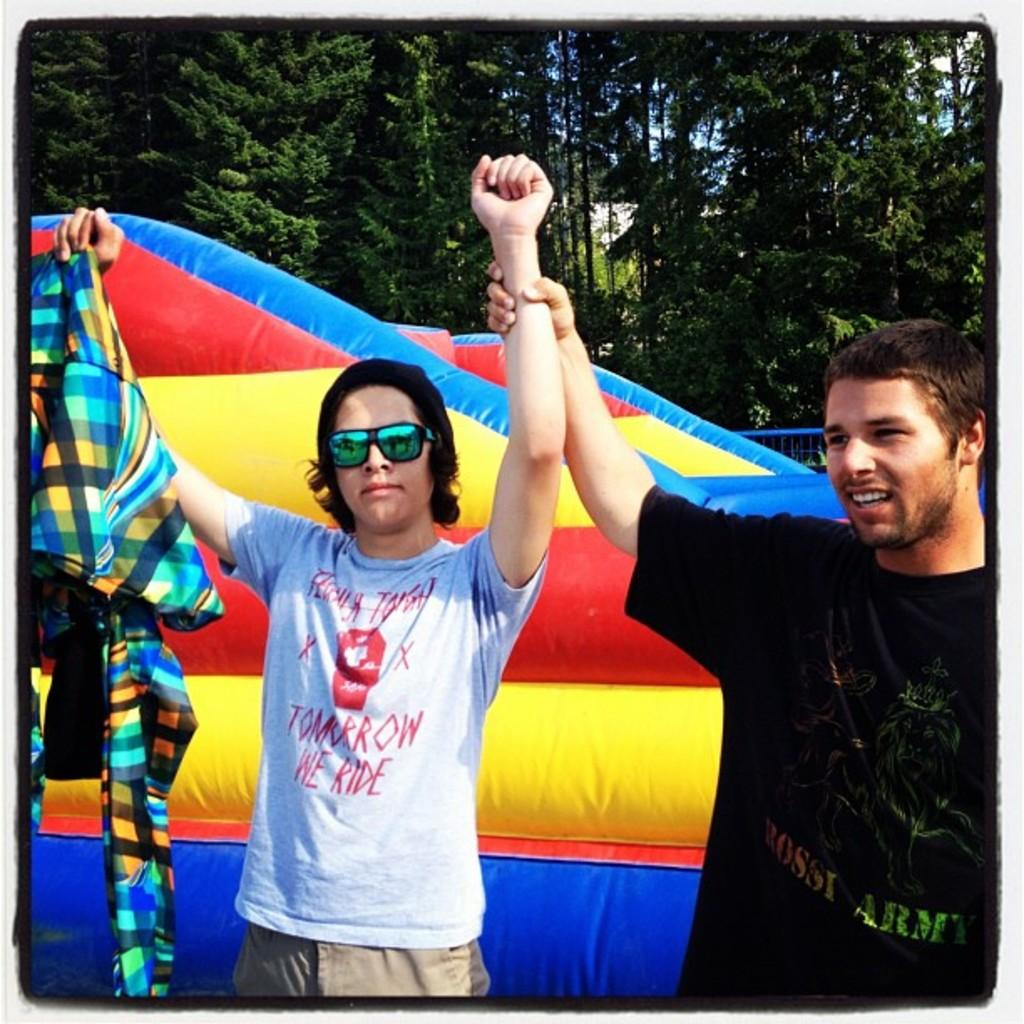How many men are in the image? There are two men in the image. What are the men doing in the image? The men are smiling in the image. What is the man on the right holding? The man on the right is holding a cloth in the image. What can be seen in the background of the image? There is an inflatable object, trees, and the sky visible in the background of the image. What type of music can be heard coming from the church in the image? There is no church present in the image, so it's not possible to determine what, if any, music might be heard. 